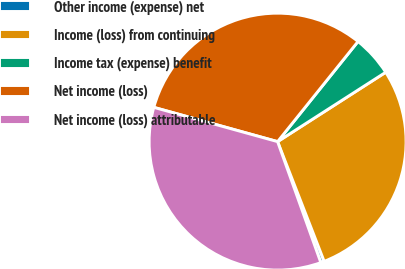Convert chart to OTSL. <chart><loc_0><loc_0><loc_500><loc_500><pie_chart><fcel>Other income (expense) net<fcel>Income (loss) from continuing<fcel>Income tax (expense) benefit<fcel>Net income (loss)<fcel>Net income (loss) attributable<nl><fcel>0.44%<fcel>28.18%<fcel>5.15%<fcel>31.47%<fcel>34.76%<nl></chart> 